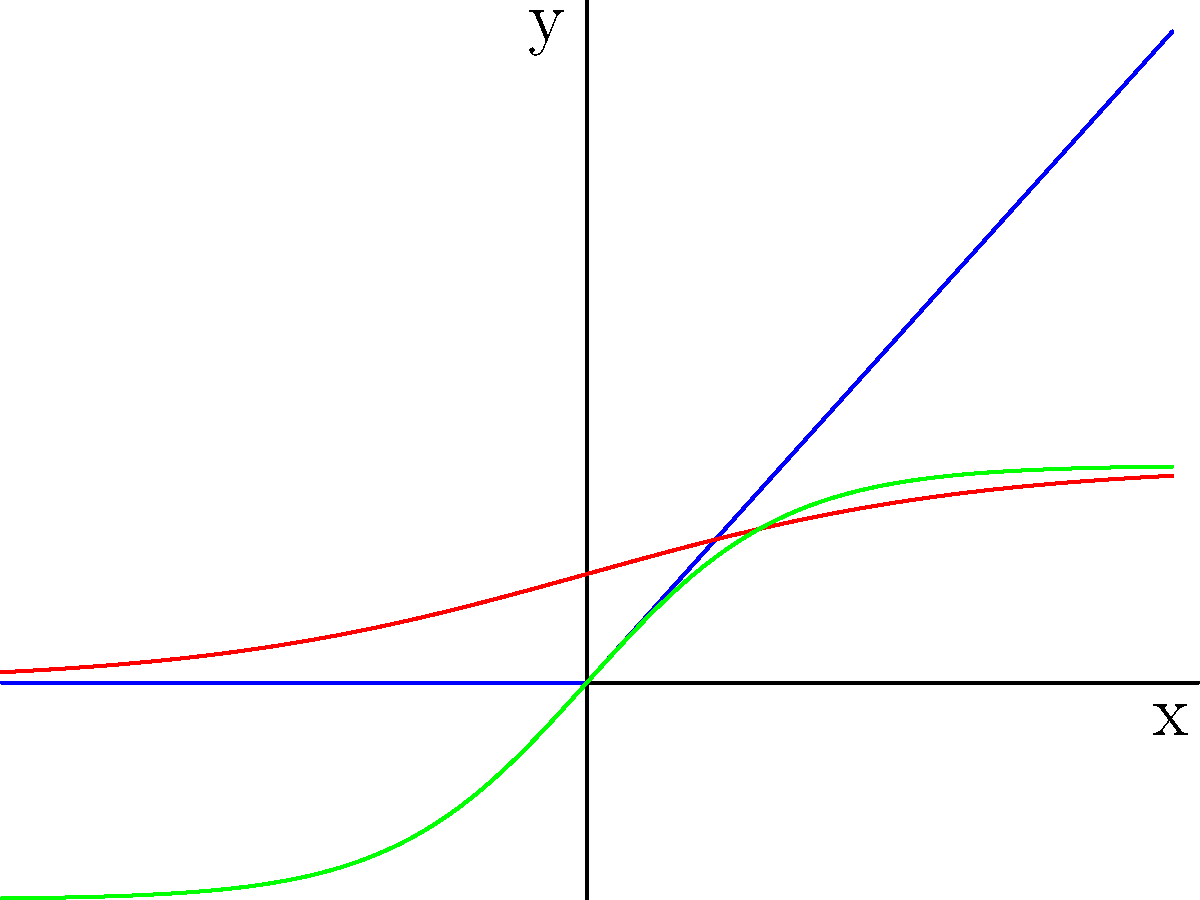As an aspiring computer scientist, you're studying different activation functions used in neural networks. Based on the graph, which activation function would be most suitable for a binary classification problem where the output needs to be between 0 and 1? Let's analyze each activation function shown in the graph:

1. ReLU (Rectified Linear Unit) - Blue line:
   - Output range: $[0, \infty)$
   - Not suitable for binary classification as it doesn't bound the output between 0 and 1

2. Sigmoid - Red line:
   - Output range: $(0, 1)$
   - Squashes input to a value between 0 and 1
   - Suitable for binary classification

3. Tanh (Hyperbolic Tangent) - Green line:
   - Output range: $(-1, 1)$
   - Not ideal for binary classification as it includes negative values

For binary classification problems where the output needs to be between 0 and 1, the Sigmoid function is the most suitable among the given options. It maps any input to a value between 0 and 1, which can be interpreted as a probability for binary classification tasks.
Answer: Sigmoid 